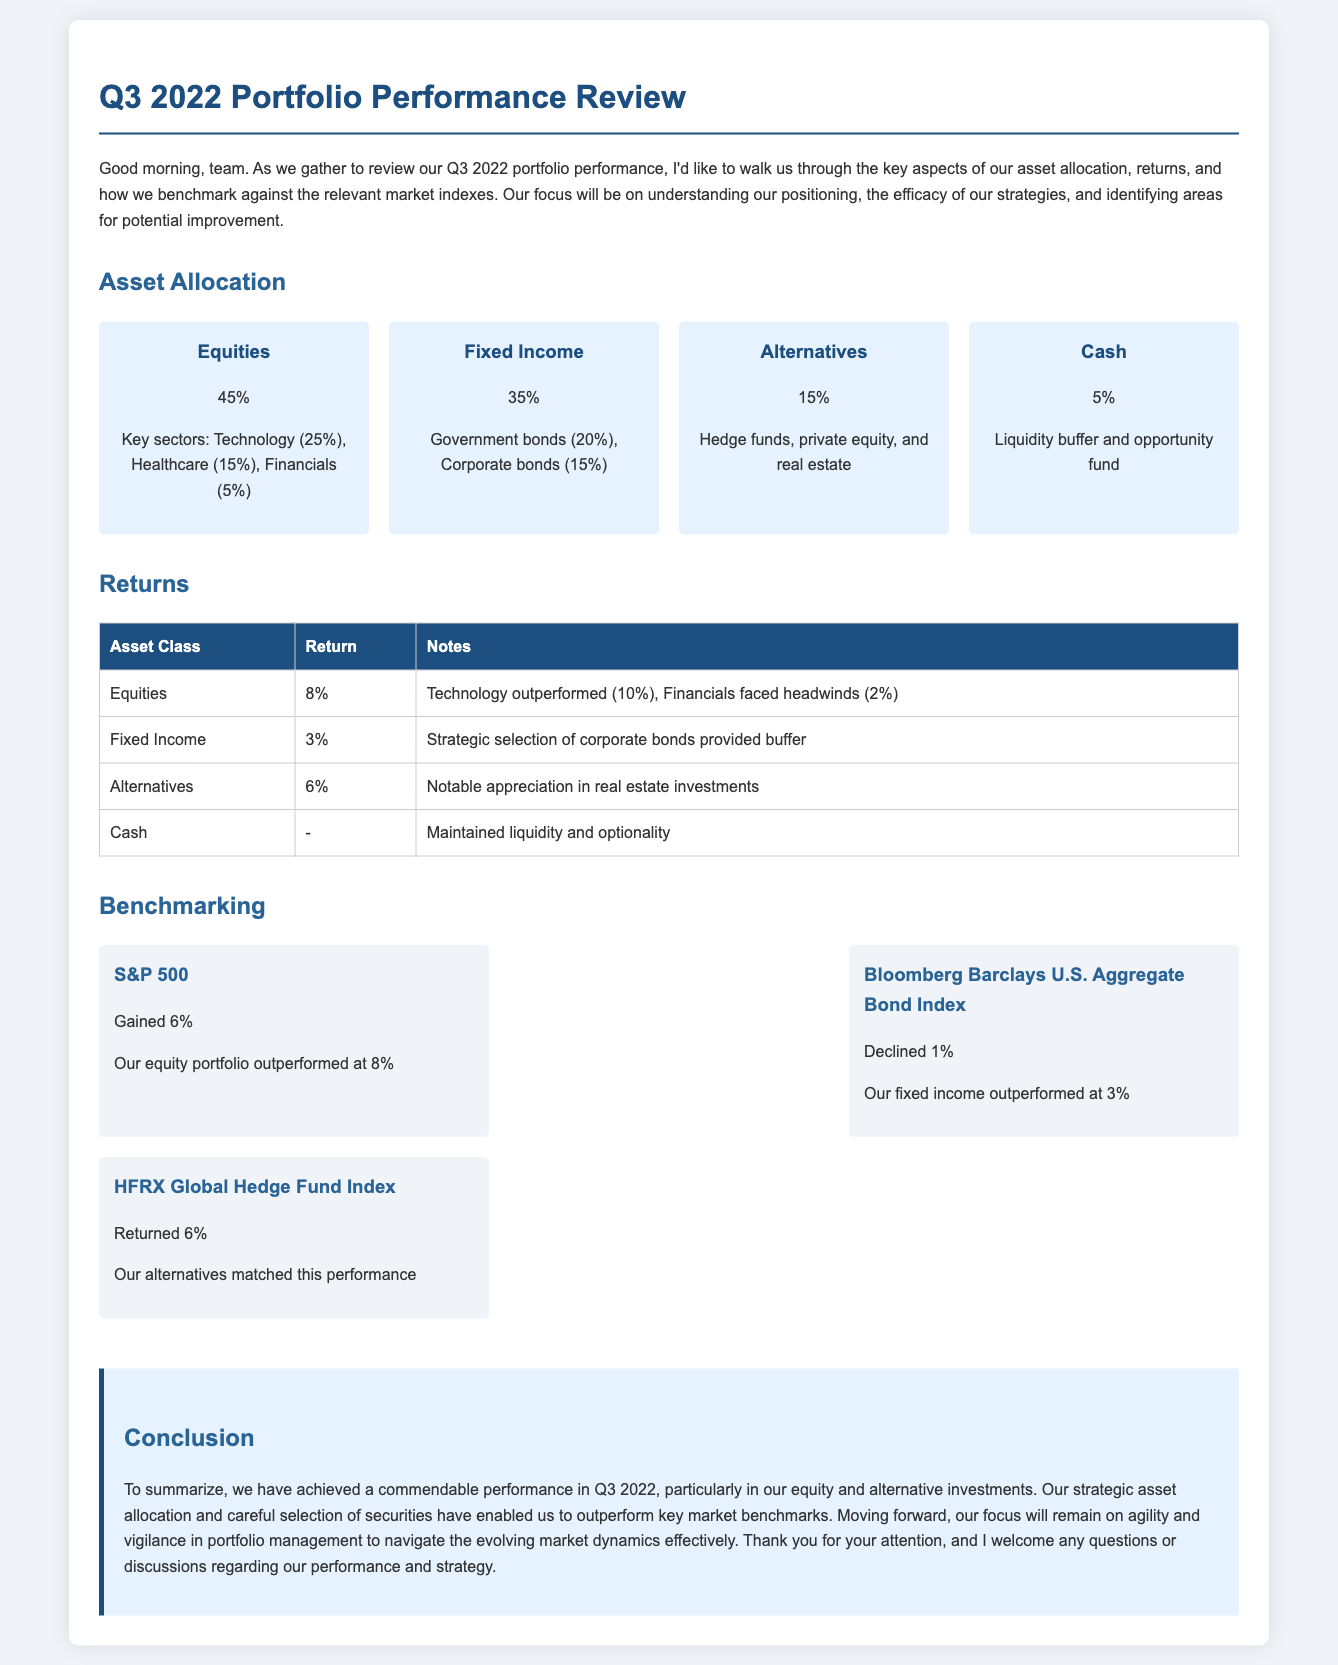What percentage of the portfolio is allocated to equities? The document states that 45% of the portfolio is allocated to equities.
Answer: 45% What was the return from fixed income investments? The return for fixed income investments, as mentioned in the document, is 3%.
Answer: 3% Which sector had the highest allocation in equities? According to the document, the Technology sector has the highest allocation in equities at 25%.
Answer: Technology What is the performance of the S&P 500 in Q3 2022? The document indicates that the S&P 500 gained 6% during Q3 2022.
Answer: Gained 6% What was the return from alternatives investments? The document lists the return from alternatives investments as 6%.
Answer: 6% How much of the portfolio is held in cash? The cash allocation in the portfolio is stated as 5% in the document.
Answer: 5% Which asset class had the largest return over Q3 2022? The largest return over Q3 2022 is from equities, with a return of 8%.
Answer: 8% What performance did our equity portfolio achieve compared to the S&P 500? The document notes that our equity portfolio outperformed the S&P 500 with a return of 8% compared to the S&P 500's gain of 6%.
Answer: Outperformed What type of bonds contributed to the fixed income buffer? Strategic selection of corporate bonds contributed to the fixed income buffer as stated in the document.
Answer: Corporate bonds 